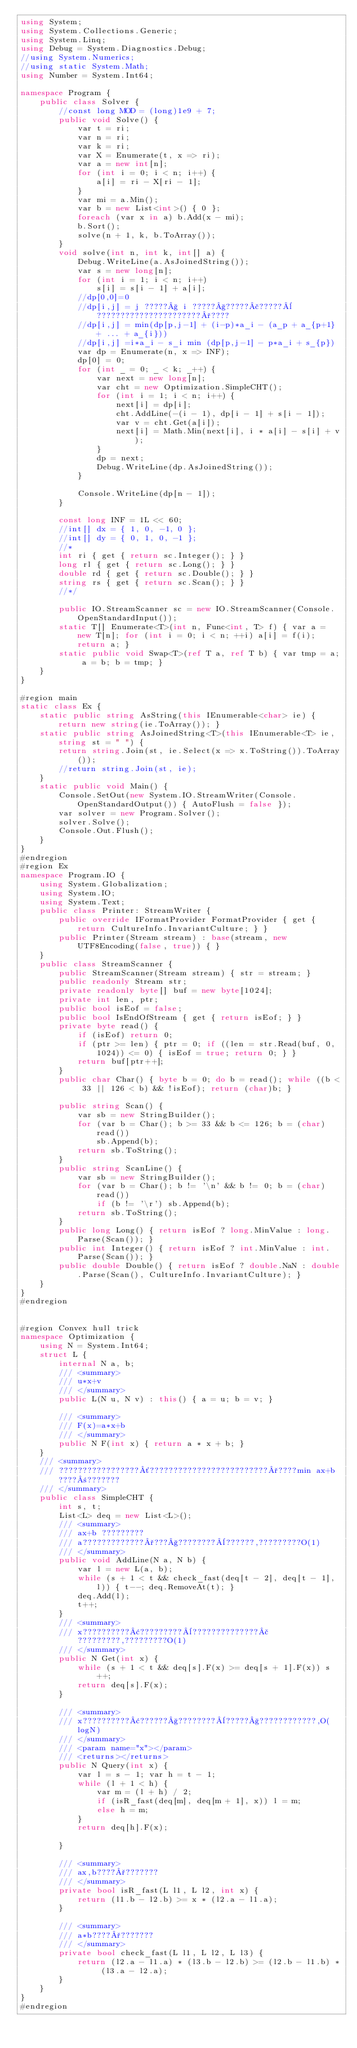Convert code to text. <code><loc_0><loc_0><loc_500><loc_500><_C#_>using System;
using System.Collections.Generic;
using System.Linq;
using Debug = System.Diagnostics.Debug;
//using System.Numerics;
//using static System.Math;
using Number = System.Int64;

namespace Program {
    public class Solver {
        //const long MOD = (long)1e9 + 7;
        public void Solve() {
            var t = ri;
            var n = ri;
            var k = ri;
            var X = Enumerate(t, x => ri);
            var a = new int[n];
            for (int i = 0; i < n; i++) {
                a[i] = ri - X[ri - 1];
            }
            var mi = a.Min();
            var b = new List<int>() { 0 };
            foreach (var x in a) b.Add(x - mi);
            b.Sort();
            solve(n + 1, k, b.ToArray());
        }
        void solve(int n, int k, int[] a) {
            Debug.WriteLine(a.AsJoinedString());
            var s = new long[n];
            for (int i = 1; i < n; i++)
                s[i] = s[i - 1] + a[i];
            //dp[0,0]=0
            //dp[i,j] = j ?????§ i ?????§?????£?????¨??????????????????????°????
            //dp[i,j] = min(dp[p,j-1] + (i-p)*a_i - (a_p + a_{p+1} + ... + a_{i}))
            //dp[i,j] =i*a_i - s_i min (dp[p,j-1] - p*a_i + s_{p})
            var dp = Enumerate(n, x => INF);
            dp[0] = 0;
            for (int _ = 0; _ < k; _++) {
                var next = new long[n];
                var cht = new Optimization.SimpleCHT();
                for (int i = 1; i < n; i++) {
                    next[i] = dp[i];
                    cht.AddLine(-(i - 1), dp[i - 1] + s[i - 1]);
                    var v = cht.Get(a[i]);
                    next[i] = Math.Min(next[i], i * a[i] - s[i] + v);
                }
                dp = next;
                Debug.WriteLine(dp.AsJoinedString());
            }

            Console.WriteLine(dp[n - 1]);
        }

        const long INF = 1L << 60;
        //int[] dx = { 1, 0, -1, 0 };
        //int[] dy = { 0, 1, 0, -1 };
        //*
        int ri { get { return sc.Integer(); } }
        long rl { get { return sc.Long(); } }
        double rd { get { return sc.Double(); } }
        string rs { get { return sc.Scan(); } }
        //*/

        public IO.StreamScanner sc = new IO.StreamScanner(Console.OpenStandardInput());
        static T[] Enumerate<T>(int n, Func<int, T> f) { var a = new T[n]; for (int i = 0; i < n; ++i) a[i] = f(i); return a; }
        static public void Swap<T>(ref T a, ref T b) { var tmp = a; a = b; b = tmp; }
    }
}

#region main
static class Ex {
    static public string AsString(this IEnumerable<char> ie) { return new string(ie.ToArray()); }
    static public string AsJoinedString<T>(this IEnumerable<T> ie, string st = " ") {
        return string.Join(st, ie.Select(x => x.ToString()).ToArray());
        //return string.Join(st, ie);
    }
    static public void Main() {
        Console.SetOut(new System.IO.StreamWriter(Console.OpenStandardOutput()) { AutoFlush = false });
        var solver = new Program.Solver();
        solver.Solve();
        Console.Out.Flush();
    }
}
#endregion
#region Ex
namespace Program.IO {
    using System.Globalization;
    using System.IO;
    using System.Text;
    public class Printer: StreamWriter {
        public override IFormatProvider FormatProvider { get { return CultureInfo.InvariantCulture; } }
        public Printer(Stream stream) : base(stream, new UTF8Encoding(false, true)) { }
    }
    public class StreamScanner {
        public StreamScanner(Stream stream) { str = stream; }
        public readonly Stream str;
        private readonly byte[] buf = new byte[1024];
        private int len, ptr;
        public bool isEof = false;
        public bool IsEndOfStream { get { return isEof; } }
        private byte read() {
            if (isEof) return 0;
            if (ptr >= len) { ptr = 0; if ((len = str.Read(buf, 0, 1024)) <= 0) { isEof = true; return 0; } }
            return buf[ptr++];
        }
        public char Char() { byte b = 0; do b = read(); while ((b < 33 || 126 < b) && !isEof); return (char)b; }

        public string Scan() {
            var sb = new StringBuilder();
            for (var b = Char(); b >= 33 && b <= 126; b = (char)read())
                sb.Append(b);
            return sb.ToString();
        }
        public string ScanLine() {
            var sb = new StringBuilder();
            for (var b = Char(); b != '\n' && b != 0; b = (char)read())
                if (b != '\r') sb.Append(b);
            return sb.ToString();
        }
        public long Long() { return isEof ? long.MinValue : long.Parse(Scan()); }
        public int Integer() { return isEof ? int.MinValue : int.Parse(Scan()); }
        public double Double() { return isEof ? double.NaN : double.Parse(Scan(), CultureInfo.InvariantCulture); }
    }
}
#endregion


#region Convex hull trick
namespace Optimization {
    using N = System.Int64;
    struct L {
        internal N a, b;
        /// <summary>
        /// u*x+v
        /// </summary>
        public L(N u, N v) : this() { a = u; b = v; }

        /// <summary>
        /// F(x)=a*x+b
        /// </summary>
        public N F(int x) { return a * x + b; }
    }
    /// <summary>
    /// ?????????????????´?????????????????????????°????min ax+b????±???????
    /// </summary>
    public class SimpleCHT {
        int s, t;
        List<L> deq = new List<L>();
        /// <summary>
        /// ax+b ?????????
        /// a?????????????°???§????????¨??????,?????????O(1)
        /// </summary>
        public void AddLine(N a, N b) {
            var l = new L(a, b);
            while (s + 1 < t && check_fast(deq[t - 2], deq[t - 1], l)) { t--; deq.RemoveAt(t); }
            deq.Add(l);
            t++;
        }
        /// <summary>
        /// x??????????¢?????????¨??????????????£?????????,?????????O(1)
        /// </summary>
        public N Get(int x) {
            while (s + 1 < t && deq[s].F(x) >= deq[s + 1].F(x)) s++;
            return deq[s].F(x);
        }

        /// <summary>
        /// x??????????¢??????§????????¨?????§????????????,O(logN)
        /// </summary>
        /// <param name="x"></param>
        /// <returns></returns>
        public N Query(int x) {
            var l = s - 1; var h = t - 1;
            while (l + 1 < h) {
                var m = (l + h) / 2;
                if (isR_fast(deq[m], deq[m + 1], x)) l = m;
                else h = m;
            }
            return deq[h].F(x);

        }

        /// <summary>
        /// ax,b????°???????
        /// </summary>
        private bool isR_fast(L l1, L l2, int x) {
            return (l1.b - l2.b) >= x * (l2.a - l1.a);
        }
      
        /// <summary>
        /// a*b????°???????
        /// </summary>
        private bool check_fast(L l1, L l2, L l3) {
            return (l2.a - l1.a) * (l3.b - l2.b) >= (l2.b - l1.b) * (l3.a - l2.a);
        }
    }
}
#endregion
</code> 